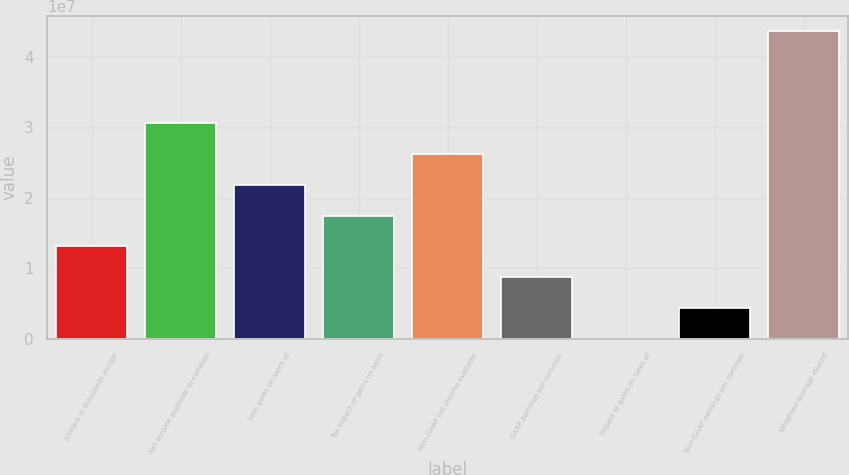Convert chart to OTSL. <chart><loc_0><loc_0><loc_500><loc_500><bar_chart><fcel>(Dollars in thousands except<fcel>Net income available to common<fcel>Less gains on sales of<fcel>Tax impact of gains on sales<fcel>Non-GAAP net income available<fcel>GAAP earnings per common<fcel>Impact of gains on sales of<fcel>Non-GAAP earnings per common<fcel>Weighted average diluted<nl><fcel>1.30911e+07<fcel>3.05458e+07<fcel>2.18184e+07<fcel>1.74547e+07<fcel>2.61821e+07<fcel>8.72737e+06<fcel>0.86<fcel>4.36369e+06<fcel>4.36369e+07<nl></chart> 